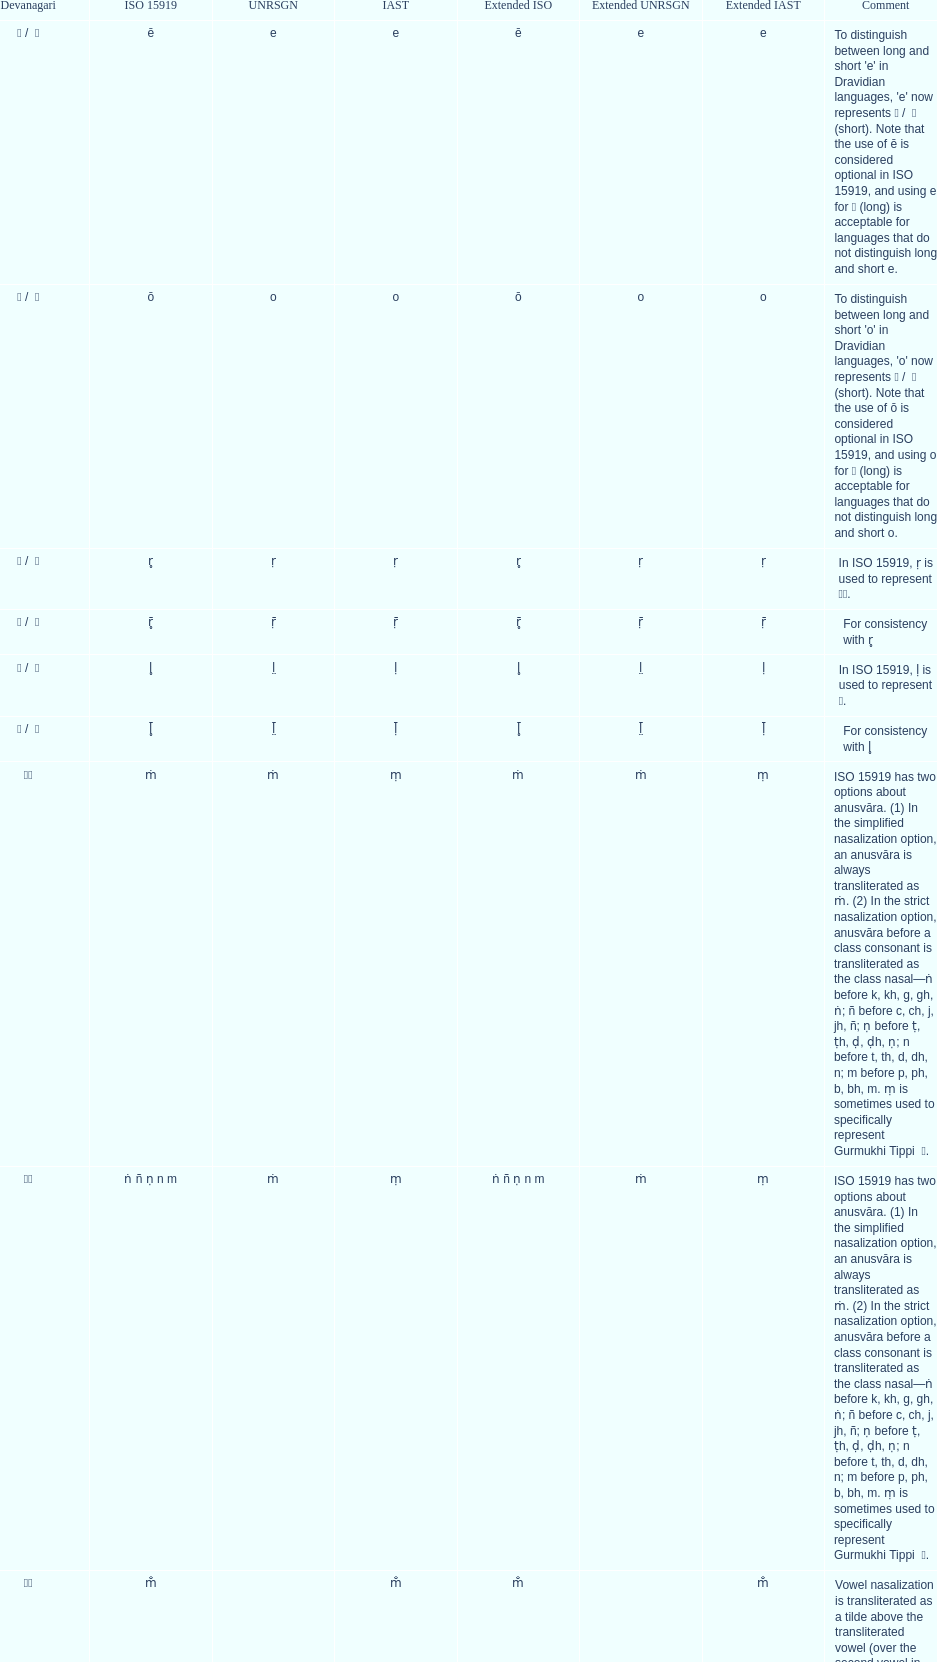Can you parse all the data within this table? {'header': ['Devanagari', 'ISO 15919', 'UNRSGN', 'IAST', 'Extended ISO', 'Extended UNRSGN', 'Extended IAST', 'Comment'], 'rows': [['ए / \xa0े', 'ē', 'e', 'e', 'ē', 'e', 'e', "To distinguish between long and short 'e' in Dravidian languages, 'e' now represents ऎ / \xa0ॆ (short). Note that the use of ē is considered optional in ISO 15919, and using e for ए (long) is acceptable for languages that do not distinguish long and short e."], ['ओ / \xa0ो', 'ō', 'o', 'o', 'ō', 'o', 'o', "To distinguish between long and short 'o' in Dravidian languages, 'o' now represents ऒ / \xa0ॊ (short). Note that the use of ō is considered optional in ISO 15919, and using o for ओ (long) is acceptable for languages that do not distinguish long and short o."], ['ऋ / \xa0ृ', 'r̥', 'ṛ', 'ṛ', 'r̥', 'ṛ', 'ṛ', 'In ISO 15919, ṛ is used to represent ड़.'], ['ॠ / \xa0ॄ', 'r̥̄', 'ṝ', 'ṝ', 'r̥̄', 'ṝ', 'ṝ', 'For consistency with r̥'], ['ऌ / \xa0ॢ', 'l̥', 'l̤', 'ḷ', 'l̥', 'l̤', 'ḷ', 'In ISO 15919, ḷ is used to represent ळ.'], ['ॡ / \xa0ॣ', 'l̥̄', 'l̤̄', 'ḹ', 'l̥̄', 'l̤̄', 'ḹ', 'For consistency with l̥'], ['◌ं', 'ṁ', 'ṁ', 'ṃ', 'ṁ', 'ṁ', 'ṃ', 'ISO 15919 has two options about anusvāra. (1) In the simplified nasalization option, an anusvāra is always transliterated as ṁ. (2) In the strict nasalization option, anusvāra before a class consonant is transliterated as the class nasal—ṅ before k, kh, g, gh, ṅ; ñ before c, ch, j, jh, ñ; ṇ before ṭ, ṭh, ḍ, ḍh, ṇ; n before t, th, d, dh, n; m before p, ph, b, bh, m. ṃ is sometimes used to specifically represent Gurmukhi Tippi \xa0ੰ.'], ['◌ं', 'ṅ ñ ṇ n m', 'ṁ', 'ṃ', 'ṅ ñ ṇ n m', 'ṁ', 'ṃ', 'ISO 15919 has two options about anusvāra. (1) In the simplified nasalization option, an anusvāra is always transliterated as ṁ. (2) In the strict nasalization option, anusvāra before a class consonant is transliterated as the class nasal—ṅ before k, kh, g, gh, ṅ; ñ before c, ch, j, jh, ñ; ṇ before ṭ, ṭh, ḍ, ḍh, ṇ; n before t, th, d, dh, n; m before p, ph, b, bh, m. ṃ is sometimes used to specifically represent Gurmukhi Tippi \xa0ੰ.'], ['◌ँ', 'm̐', '', 'm̐', 'm̐', '', 'm̐', 'Vowel nasalization is transliterated as a tilde above the transliterated vowel (over the second vowel in the case of a digraph such as aĩ, aũ), except in Sanskrit.']]} How many total options are there about anusvara? 2. 